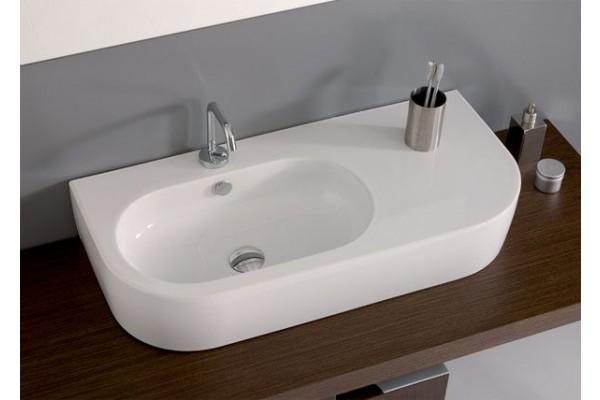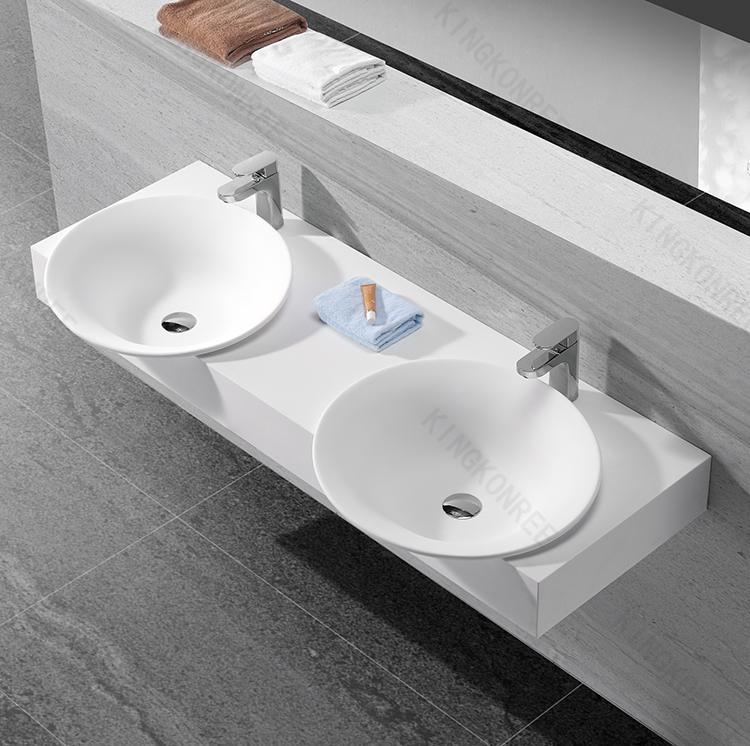The first image is the image on the left, the second image is the image on the right. Examine the images to the left and right. Is the description "There are two basins on the counter in the image on the right." accurate? Answer yes or no. Yes. The first image is the image on the left, the second image is the image on the right. Analyze the images presented: Is the assertion "A bathroom double sink installation has one upright chrome faucet fixture situated behind the bowl of each sink" valid? Answer yes or no. Yes. 